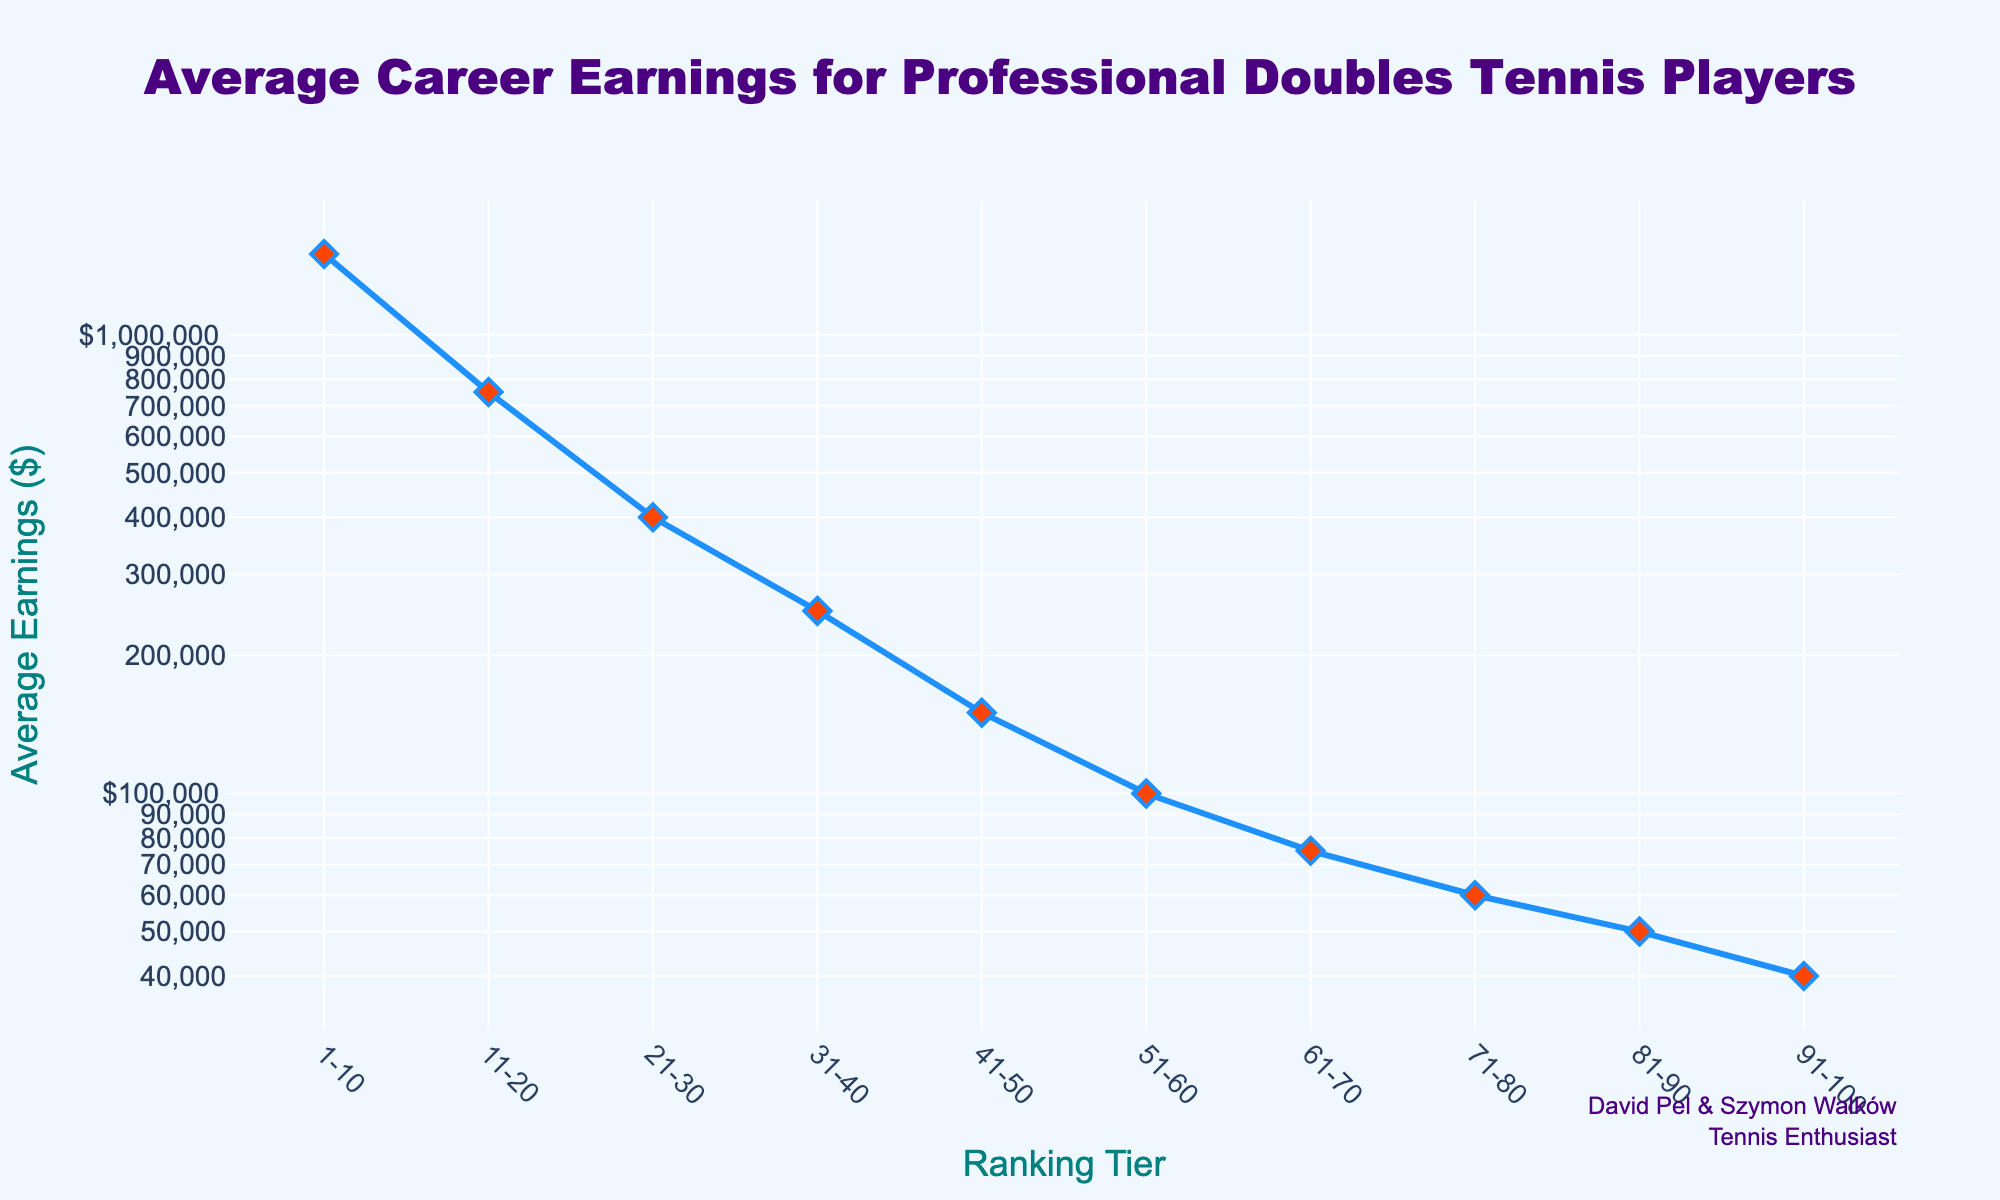What's the title of the plot? The title is at the top center of the figure.
Answer: Average Career Earnings for Professional Doubles Tennis Players What are the y-axis and x-axis titles? The axis titles are directly below the x-axis and to the side of the y-axis.
Answer: x-axis: Ranking Tier, y-axis: Average Earnings ($) How does the average earnings change as the ranking tier increases? By observing the trend in the line plot, we can see that average earnings decrease as the ranking tier goes from 1-10 to 91-100.
Answer: Decreases What is the average earnings for the ranking tier 1-10? Locate the ranking tier 1-10 on the x-axis and read the y-axis value at that point (1500000).
Answer: $1,500,000 Which ranking tier has the lowest average earnings, and what is that amount? Find the lowest point on the y-axis, then look at the corresponding x-axis value. For the ranking tier 91-100, average earnings are $40,000.
Answer: 91-100, $40,000 How many ranking tiers are displayed in the plot? Count the number of distinct points along the x-axis. There are 10 distinct ranking tiers shown.
Answer: 10 What is the difference in average earnings between the ranking tiers of 21-30 and 51-60? Subtract the average earnings of the ranking tier 51-60 from that of 21-30 ($400,000 - $100,000).
Answer: $300,000 How many ranking tiers have average earnings equal to or greater than $100,000? Identify the points on the y-axis that show $100,000 or more and count how many ranking tiers correspond to these points: 1-10, 11-20, 21-30, 31-40, and 41-50.
Answer: 5 Compare the average earnings of ranking tiers 1-10 and 11-20. How much higher are the earnings in 1-10? Subtract the average earnings of 11-20 from that of 1-10 ($1,500,000 - $750,000).
Answer: $750,000 How much do the average earnings decrease from ranking tier 1-10 to 41-50? Subtract the average earnings of 41-50 from that of 1-10 ($1,500,000 - $150,000).
Answer: $1,350,000 